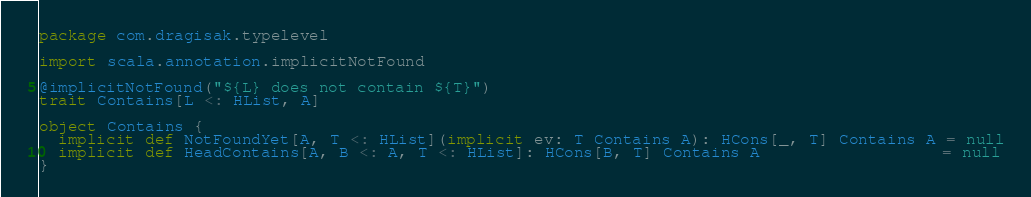<code> <loc_0><loc_0><loc_500><loc_500><_Scala_>package com.dragisak.typelevel

import scala.annotation.implicitNotFound

@implicitNotFound("${L} does not contain ${T}")
trait Contains[L <: HList, A]

object Contains {
  implicit def NotFoundYet[A, T <: HList](implicit ev: T Contains A): HCons[_, T] Contains A = null
  implicit def HeadContains[A, B <: A, T <: HList]: HCons[B, T] Contains A                   = null
}
</code> 